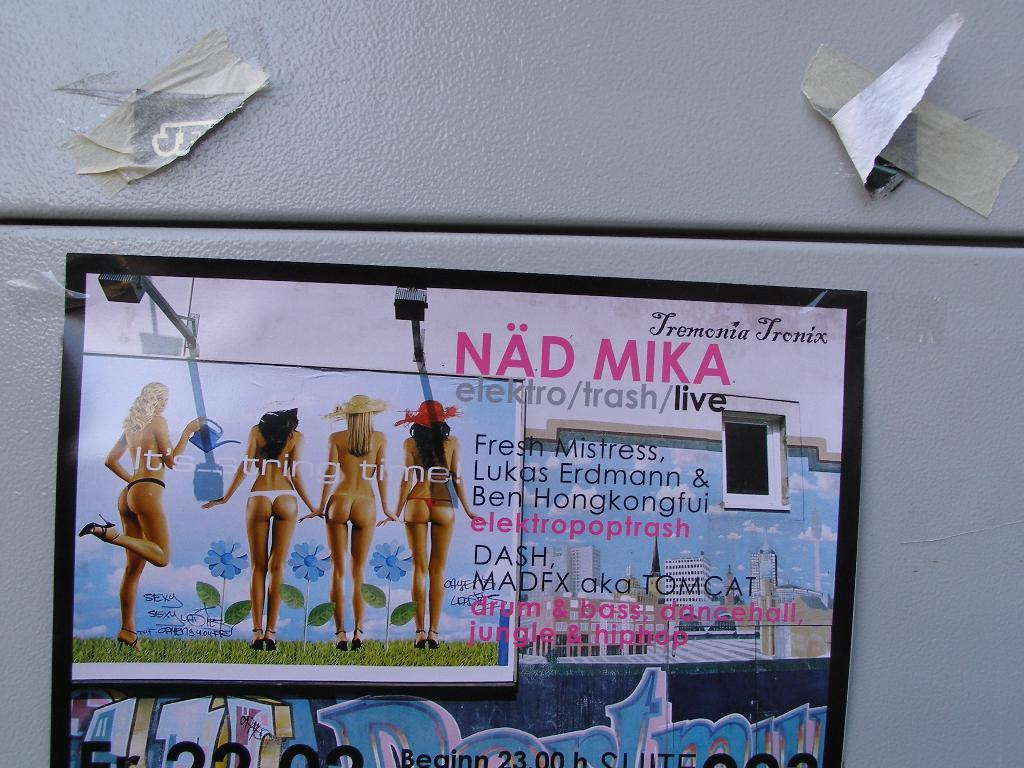What is located in the middle of the image? There is a poster in the middle of the image. What can be seen on the left side of the image? There are women standing on the left side of the image. What is present on the right side of the image? There is text on the right side of the image. What objects are visible at the top of the image? Paper pieces are visible at the top of the image. Is there a party happening in the image? There is no indication of a party in the image. Can you see any smoke coming from the poster? There is no smoke present in the image. 